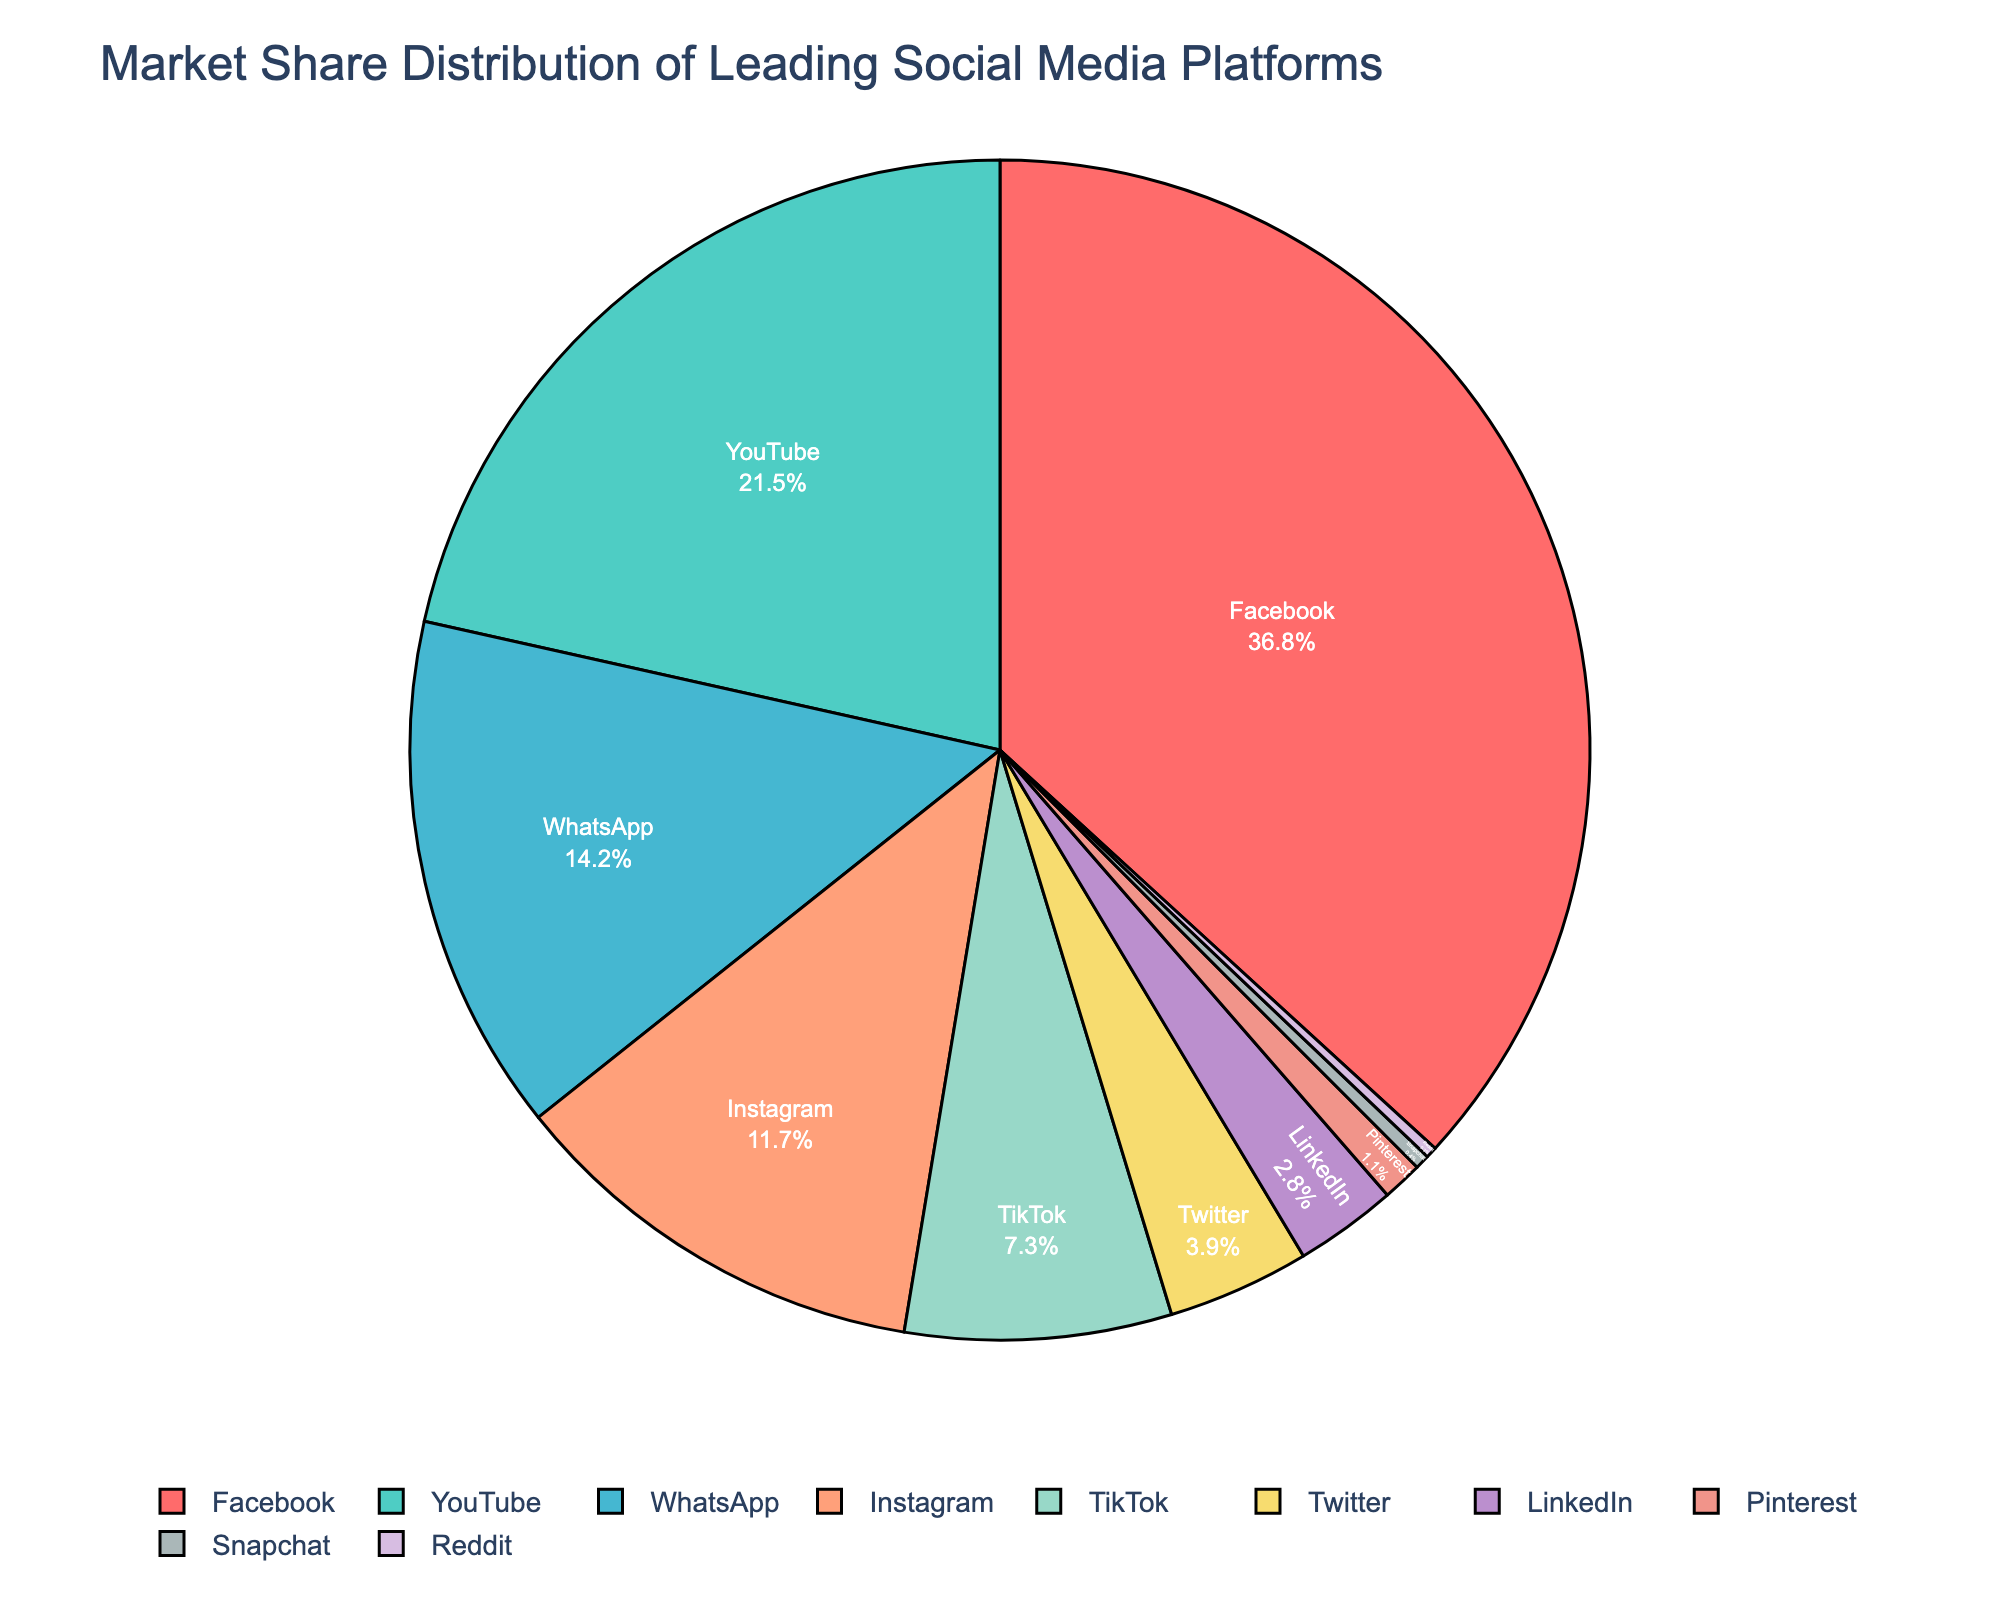What's the market share of the leading social media platform? The leader in market share is the largest segment in the pie chart. Facebook is shown as the largest segment, so its market share is 36.8%.
Answer: 36.8% Which social media platform has the second highest market share? The platform with the second largest segment in the pie chart is YouTube, representing 21.5% of the market share.
Answer: YouTube What is the combined market share of WhatsApp and Instagram? The market share of WhatsApp is 14.2%, and the market share of Instagram is 11.7%. Adding these together, 14.2% + 11.7% = 25.9%.
Answer: 25.9% How much larger is Facebook's market share compared to TikTok's? Facebook's market share is 36.8%, and TikTok's market share is 7.3%. Subtracting these gives 36.8% - 7.3% = 29.5%.
Answer: 29.5% Is LinkedIn's market share greater than Pinterest's market share? LinkedIn has a market share of 2.8%, while Pinterest has a market share of 1.1%. Since 2.8% is greater than 1.1%, LinkedIn has a larger market share.
Answer: Yes What are the colors representing Facebook and YouTube in the pie chart? Facebook is represented by the color red, and YouTube is represented by the color teal. These colors are used to differentiate platforms in the pie chart visually.
Answer: Red and teal What percentage of market share do the three smallest platforms hold combined? The market shares of the three smallest platforms are Snapchat (0.4%), Reddit (0.3%), and Pinterest (1.1%). Adding these together, 0.4% + 0.3% + 1.1% = 1.8%.
Answer: 1.8% Which platforms' segments in the pie chart are displayed in shades of blue? The platforms shown in shades of blue are YouTube and TikTok. These segments help identify the platforms visually.
Answer: YouTube and TikTok What is the difference in market share between Instagram and Twitter? Instagram has a market share of 11.7%, and Twitter has a market share of 3.9%. The difference is calculated as 11.7% - 3.9% = 7.8%.
Answer: 7.8% Which platform has a market share that is closest to 5%? TikTok has a market share of 7.3%, which is the closest to 5% among all platforms in the pie chart.
Answer: TikTok 